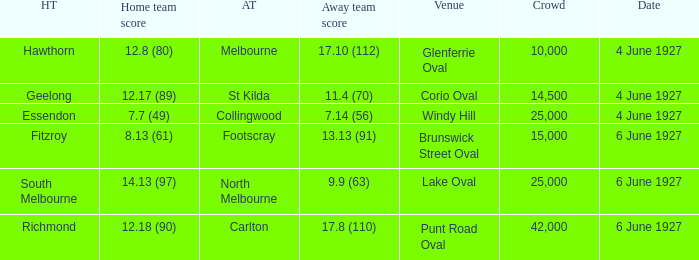Which team was at Corio Oval on 4 June 1927? St Kilda. 